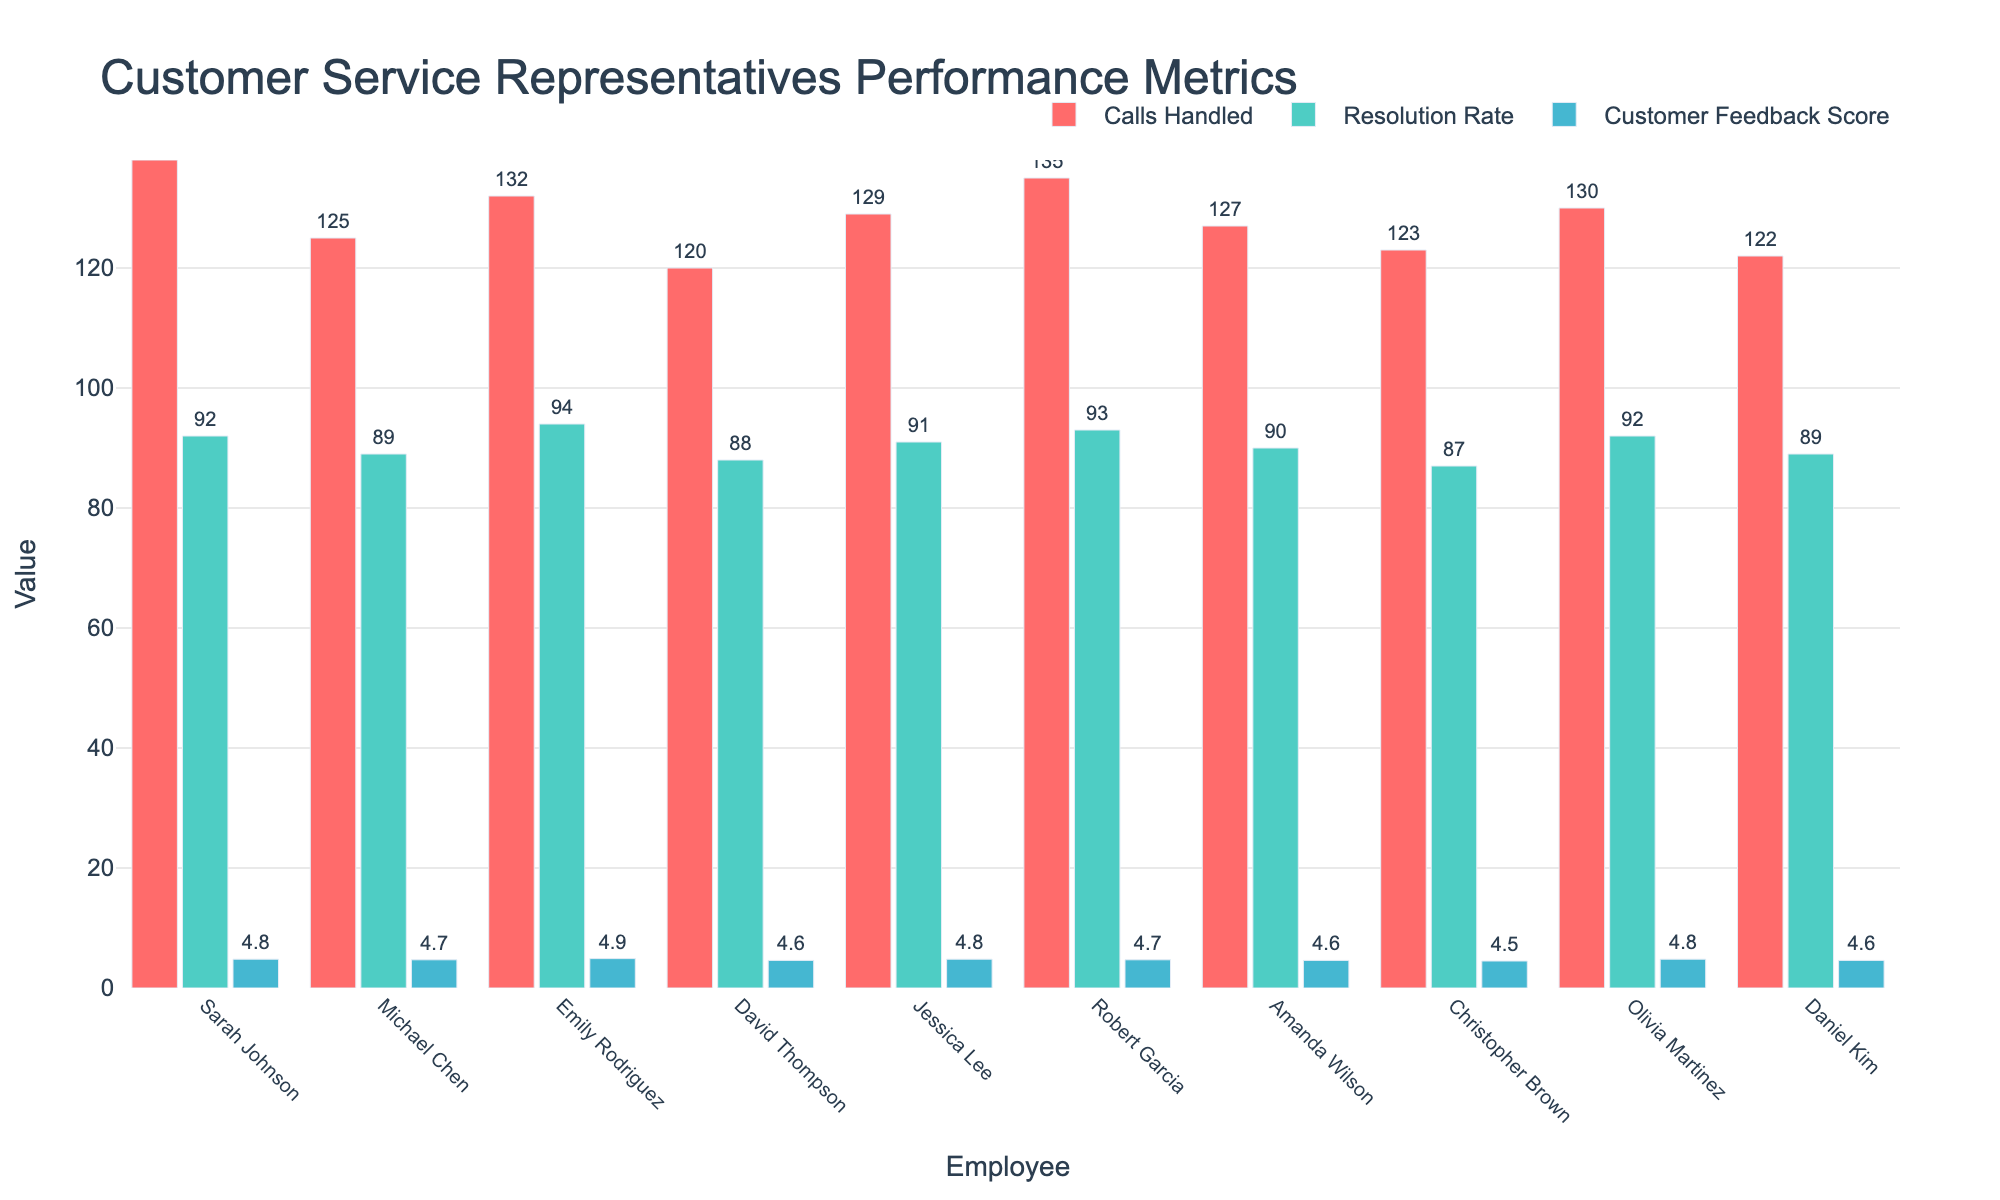Which employee handled the most calls? To find this, look at the bars representing "Calls Handled" for each employee and identify the highest bar. Sarah Johnson handled 138 calls, which is the highest number.
Answer: Sarah Johnson What is the average Customer Feedback Score for the top 10 representatives? Sum all the customer feedback scores (4.8 + 4.7 + 4.9 + 4.6 + 4.8 + 4.7 + 4.6 + 4.5 + 4.8 + 4.6) to get 47. Subtract the sum of the customer feedback scores by the total number of employees (47/10) to find the average score.
Answer: 4.7 Who has a higher resolution rate, Robert Garcia or Michael Chen? Compare the bars representing "Resolution Rate" for Robert Garcia and Michael Chen. Robert Garcia has a resolution rate of 93%, and Michael Chen has 89%.
Answer: Robert Garcia Compare the number of calls handled by Emily Rodriguez and David Thompson. Who handled more calls and by how many? Look at the bars representing "Calls Handled" for Emily Rodriguez and David Thompson. Emily handled 132 calls, and David handled 120 calls. The difference is 132 - 120, which equals 12.
Answer: Emily Rodriguez, by 12 Between Amanda Wilson and Daniel Kim, whose Customer Feedback Score is higher? Locate the bars representing "Customer Feedback Score" for Amanda Wilson and Daniel Kim. Amanda Wilson has a score of 4.6, while Daniel Kim also has a score of 4.6.
Answer: Both are equal Which employee has the highest Resolution Rate and what is the value? Scan the bars representing "Resolution Rate" and identify the highest one. Emily Rodriguez has the highest resolution rate at 94%.
Answer: Emily Rodriguez, 94% How many employees have a Customer Feedback Score of 4.8? Count the number of bars representing "Customer Feedback Score" that reach up to 4.8. Sarah Johnson, Jessica Lee, and Olivia Martinez each have a score of 4.8.
Answer: 3 What is the combined sum of the calls handled by Olivia Martinez and Michael Chen? Add the "Calls Handled" values for both Olivia Martinez and Michael Chen. Olivia handled 130 calls, and Michael handled 125 calls. The combined sum is 130 + 125.
Answer: 255 Between Christopher Brown and Amanda Wilson, who has a better resolution rate and by how much? Compare the "Resolution Rate" bars of both employees. Christopher has a rate of 87%, and Amanda has 90%. The difference is 90% - 87%.
Answer: Amanda Wilson, by 3% Compare the Customer Feedback Score of the best performer in terms of Resolution Rate to the worst performer in terms of Calls Handled. What is the difference? The best performer in terms of Resolution Rate is Emily Rodriguez with a score of 94%. The worst performer in terms of Calls Handled is David Thompson with 120 calls and a Customer Feedback Score of 4.6. The difference is 4.9 - 4.6.
Answer: 0.3 